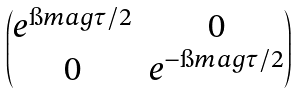<formula> <loc_0><loc_0><loc_500><loc_500>\begin{pmatrix} e ^ { \i m a g \tau / 2 } & 0 \\ 0 & e ^ { - \i m a g \tau / 2 } \end{pmatrix}</formula> 